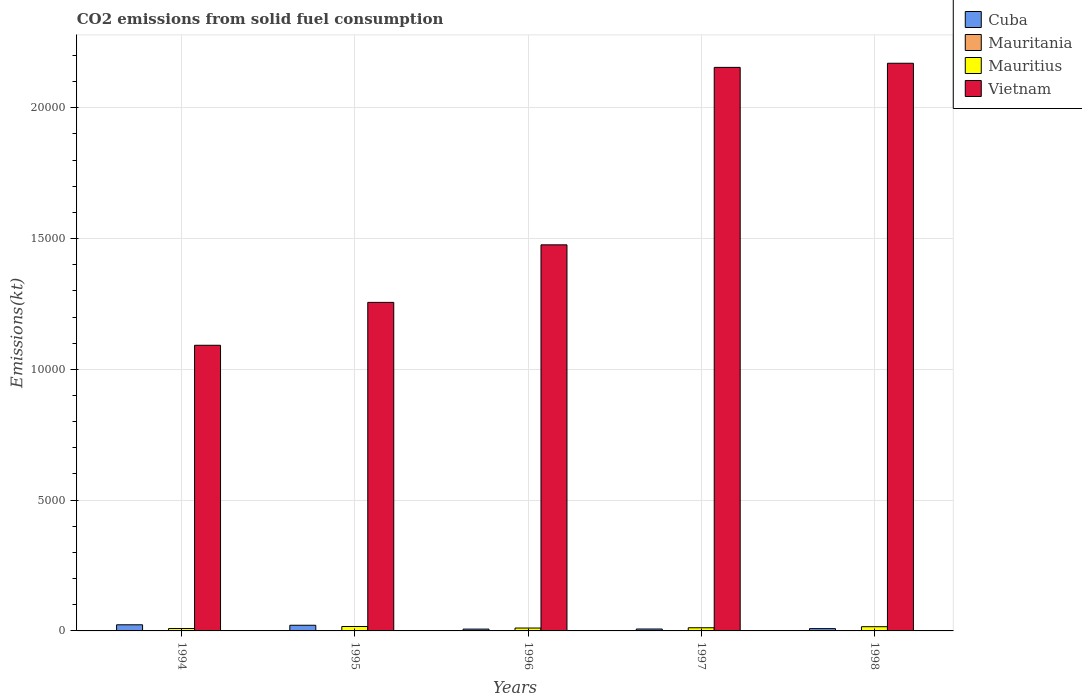How many groups of bars are there?
Offer a terse response. 5. How many bars are there on the 4th tick from the left?
Your response must be concise. 4. How many bars are there on the 1st tick from the right?
Ensure brevity in your answer.  4. What is the amount of CO2 emitted in Mauritius in 1998?
Make the answer very short. 161.35. Across all years, what is the maximum amount of CO2 emitted in Vietnam?
Make the answer very short. 2.17e+04. Across all years, what is the minimum amount of CO2 emitted in Vietnam?
Offer a terse response. 1.09e+04. In which year was the amount of CO2 emitted in Vietnam maximum?
Keep it short and to the point. 1998. In which year was the amount of CO2 emitted in Cuba minimum?
Keep it short and to the point. 1996. What is the total amount of CO2 emitted in Mauritius in the graph?
Your answer should be very brief. 652.73. What is the difference between the amount of CO2 emitted in Cuba in 1995 and that in 1996?
Your response must be concise. 146.68. What is the difference between the amount of CO2 emitted in Mauritius in 1998 and the amount of CO2 emitted in Cuba in 1994?
Your response must be concise. -73.34. What is the average amount of CO2 emitted in Mauritania per year?
Give a very brief answer. 8.07. In the year 1998, what is the difference between the amount of CO2 emitted in Vietnam and amount of CO2 emitted in Cuba?
Provide a succinct answer. 2.16e+04. What is the ratio of the amount of CO2 emitted in Cuba in 1995 to that in 1997?
Offer a very short reply. 2.95. Is the difference between the amount of CO2 emitted in Vietnam in 1996 and 1998 greater than the difference between the amount of CO2 emitted in Cuba in 1996 and 1998?
Give a very brief answer. No. What is the difference between the highest and the second highest amount of CO2 emitted in Vietnam?
Make the answer very short. 157.68. What is the difference between the highest and the lowest amount of CO2 emitted in Cuba?
Your answer should be compact. 165.01. Is it the case that in every year, the sum of the amount of CO2 emitted in Cuba and amount of CO2 emitted in Mauritius is greater than the sum of amount of CO2 emitted in Mauritania and amount of CO2 emitted in Vietnam?
Your answer should be compact. Yes. What does the 3rd bar from the left in 1996 represents?
Your answer should be very brief. Mauritius. What does the 3rd bar from the right in 1997 represents?
Give a very brief answer. Mauritania. Is it the case that in every year, the sum of the amount of CO2 emitted in Cuba and amount of CO2 emitted in Mauritius is greater than the amount of CO2 emitted in Vietnam?
Provide a succinct answer. No. Does the graph contain grids?
Your answer should be very brief. Yes. What is the title of the graph?
Keep it short and to the point. CO2 emissions from solid fuel consumption. Does "Zambia" appear as one of the legend labels in the graph?
Keep it short and to the point. No. What is the label or title of the Y-axis?
Your response must be concise. Emissions(kt). What is the Emissions(kt) in Cuba in 1994?
Your answer should be compact. 234.69. What is the Emissions(kt) in Mauritania in 1994?
Your answer should be very brief. 14.67. What is the Emissions(kt) of Mauritius in 1994?
Give a very brief answer. 91.67. What is the Emissions(kt) of Vietnam in 1994?
Give a very brief answer. 1.09e+04. What is the Emissions(kt) in Cuba in 1995?
Ensure brevity in your answer.  216.35. What is the Emissions(kt) in Mauritania in 1995?
Offer a very short reply. 11. What is the Emissions(kt) of Mauritius in 1995?
Offer a terse response. 168.68. What is the Emissions(kt) of Vietnam in 1995?
Ensure brevity in your answer.  1.26e+04. What is the Emissions(kt) in Cuba in 1996?
Offer a terse response. 69.67. What is the Emissions(kt) of Mauritania in 1996?
Keep it short and to the point. 7.33. What is the Emissions(kt) in Mauritius in 1996?
Provide a short and direct response. 110.01. What is the Emissions(kt) in Vietnam in 1996?
Offer a terse response. 1.48e+04. What is the Emissions(kt) in Cuba in 1997?
Your answer should be compact. 73.34. What is the Emissions(kt) of Mauritania in 1997?
Your response must be concise. 3.67. What is the Emissions(kt) of Mauritius in 1997?
Ensure brevity in your answer.  121.01. What is the Emissions(kt) of Vietnam in 1997?
Ensure brevity in your answer.  2.15e+04. What is the Emissions(kt) in Cuba in 1998?
Provide a short and direct response. 88.01. What is the Emissions(kt) of Mauritania in 1998?
Your answer should be very brief. 3.67. What is the Emissions(kt) of Mauritius in 1998?
Your response must be concise. 161.35. What is the Emissions(kt) in Vietnam in 1998?
Make the answer very short. 2.17e+04. Across all years, what is the maximum Emissions(kt) in Cuba?
Make the answer very short. 234.69. Across all years, what is the maximum Emissions(kt) of Mauritania?
Give a very brief answer. 14.67. Across all years, what is the maximum Emissions(kt) in Mauritius?
Ensure brevity in your answer.  168.68. Across all years, what is the maximum Emissions(kt) of Vietnam?
Keep it short and to the point. 2.17e+04. Across all years, what is the minimum Emissions(kt) of Cuba?
Your response must be concise. 69.67. Across all years, what is the minimum Emissions(kt) in Mauritania?
Give a very brief answer. 3.67. Across all years, what is the minimum Emissions(kt) in Mauritius?
Ensure brevity in your answer.  91.67. Across all years, what is the minimum Emissions(kt) in Vietnam?
Your answer should be compact. 1.09e+04. What is the total Emissions(kt) in Cuba in the graph?
Your answer should be compact. 682.06. What is the total Emissions(kt) in Mauritania in the graph?
Offer a terse response. 40.34. What is the total Emissions(kt) in Mauritius in the graph?
Give a very brief answer. 652.73. What is the total Emissions(kt) of Vietnam in the graph?
Offer a very short reply. 8.15e+04. What is the difference between the Emissions(kt) of Cuba in 1994 and that in 1995?
Your answer should be compact. 18.34. What is the difference between the Emissions(kt) of Mauritania in 1994 and that in 1995?
Provide a succinct answer. 3.67. What is the difference between the Emissions(kt) in Mauritius in 1994 and that in 1995?
Provide a succinct answer. -77.01. What is the difference between the Emissions(kt) of Vietnam in 1994 and that in 1995?
Make the answer very short. -1639.15. What is the difference between the Emissions(kt) in Cuba in 1994 and that in 1996?
Offer a very short reply. 165.01. What is the difference between the Emissions(kt) in Mauritania in 1994 and that in 1996?
Your answer should be very brief. 7.33. What is the difference between the Emissions(kt) of Mauritius in 1994 and that in 1996?
Provide a succinct answer. -18.34. What is the difference between the Emissions(kt) of Vietnam in 1994 and that in 1996?
Offer a terse response. -3839.35. What is the difference between the Emissions(kt) of Cuba in 1994 and that in 1997?
Keep it short and to the point. 161.35. What is the difference between the Emissions(kt) of Mauritania in 1994 and that in 1997?
Give a very brief answer. 11. What is the difference between the Emissions(kt) of Mauritius in 1994 and that in 1997?
Your answer should be compact. -29.34. What is the difference between the Emissions(kt) in Vietnam in 1994 and that in 1997?
Ensure brevity in your answer.  -1.06e+04. What is the difference between the Emissions(kt) in Cuba in 1994 and that in 1998?
Offer a very short reply. 146.68. What is the difference between the Emissions(kt) of Mauritania in 1994 and that in 1998?
Provide a short and direct response. 11. What is the difference between the Emissions(kt) of Mauritius in 1994 and that in 1998?
Ensure brevity in your answer.  -69.67. What is the difference between the Emissions(kt) of Vietnam in 1994 and that in 1998?
Provide a short and direct response. -1.08e+04. What is the difference between the Emissions(kt) of Cuba in 1995 and that in 1996?
Provide a succinct answer. 146.68. What is the difference between the Emissions(kt) of Mauritania in 1995 and that in 1996?
Provide a short and direct response. 3.67. What is the difference between the Emissions(kt) in Mauritius in 1995 and that in 1996?
Your answer should be compact. 58.67. What is the difference between the Emissions(kt) in Vietnam in 1995 and that in 1996?
Provide a short and direct response. -2200.2. What is the difference between the Emissions(kt) of Cuba in 1995 and that in 1997?
Your answer should be very brief. 143.01. What is the difference between the Emissions(kt) of Mauritania in 1995 and that in 1997?
Make the answer very short. 7.33. What is the difference between the Emissions(kt) in Mauritius in 1995 and that in 1997?
Offer a terse response. 47.67. What is the difference between the Emissions(kt) of Vietnam in 1995 and that in 1997?
Your answer should be very brief. -8984.15. What is the difference between the Emissions(kt) of Cuba in 1995 and that in 1998?
Offer a terse response. 128.34. What is the difference between the Emissions(kt) in Mauritania in 1995 and that in 1998?
Offer a terse response. 7.33. What is the difference between the Emissions(kt) in Mauritius in 1995 and that in 1998?
Give a very brief answer. 7.33. What is the difference between the Emissions(kt) of Vietnam in 1995 and that in 1998?
Your response must be concise. -9141.83. What is the difference between the Emissions(kt) of Cuba in 1996 and that in 1997?
Provide a short and direct response. -3.67. What is the difference between the Emissions(kt) of Mauritania in 1996 and that in 1997?
Provide a short and direct response. 3.67. What is the difference between the Emissions(kt) of Mauritius in 1996 and that in 1997?
Provide a succinct answer. -11. What is the difference between the Emissions(kt) in Vietnam in 1996 and that in 1997?
Provide a short and direct response. -6783.95. What is the difference between the Emissions(kt) in Cuba in 1996 and that in 1998?
Keep it short and to the point. -18.34. What is the difference between the Emissions(kt) of Mauritania in 1996 and that in 1998?
Your response must be concise. 3.67. What is the difference between the Emissions(kt) of Mauritius in 1996 and that in 1998?
Offer a very short reply. -51.34. What is the difference between the Emissions(kt) in Vietnam in 1996 and that in 1998?
Ensure brevity in your answer.  -6941.63. What is the difference between the Emissions(kt) of Cuba in 1997 and that in 1998?
Your answer should be very brief. -14.67. What is the difference between the Emissions(kt) of Mauritania in 1997 and that in 1998?
Your answer should be very brief. 0. What is the difference between the Emissions(kt) of Mauritius in 1997 and that in 1998?
Provide a short and direct response. -40.34. What is the difference between the Emissions(kt) of Vietnam in 1997 and that in 1998?
Provide a short and direct response. -157.68. What is the difference between the Emissions(kt) of Cuba in 1994 and the Emissions(kt) of Mauritania in 1995?
Offer a very short reply. 223.69. What is the difference between the Emissions(kt) of Cuba in 1994 and the Emissions(kt) of Mauritius in 1995?
Your answer should be very brief. 66.01. What is the difference between the Emissions(kt) in Cuba in 1994 and the Emissions(kt) in Vietnam in 1995?
Your response must be concise. -1.23e+04. What is the difference between the Emissions(kt) of Mauritania in 1994 and the Emissions(kt) of Mauritius in 1995?
Your answer should be very brief. -154.01. What is the difference between the Emissions(kt) in Mauritania in 1994 and the Emissions(kt) in Vietnam in 1995?
Provide a short and direct response. -1.25e+04. What is the difference between the Emissions(kt) of Mauritius in 1994 and the Emissions(kt) of Vietnam in 1995?
Offer a very short reply. -1.25e+04. What is the difference between the Emissions(kt) in Cuba in 1994 and the Emissions(kt) in Mauritania in 1996?
Give a very brief answer. 227.35. What is the difference between the Emissions(kt) of Cuba in 1994 and the Emissions(kt) of Mauritius in 1996?
Make the answer very short. 124.68. What is the difference between the Emissions(kt) in Cuba in 1994 and the Emissions(kt) in Vietnam in 1996?
Make the answer very short. -1.45e+04. What is the difference between the Emissions(kt) of Mauritania in 1994 and the Emissions(kt) of Mauritius in 1996?
Offer a very short reply. -95.34. What is the difference between the Emissions(kt) of Mauritania in 1994 and the Emissions(kt) of Vietnam in 1996?
Offer a very short reply. -1.47e+04. What is the difference between the Emissions(kt) in Mauritius in 1994 and the Emissions(kt) in Vietnam in 1996?
Ensure brevity in your answer.  -1.47e+04. What is the difference between the Emissions(kt) of Cuba in 1994 and the Emissions(kt) of Mauritania in 1997?
Provide a short and direct response. 231.02. What is the difference between the Emissions(kt) of Cuba in 1994 and the Emissions(kt) of Mauritius in 1997?
Keep it short and to the point. 113.68. What is the difference between the Emissions(kt) in Cuba in 1994 and the Emissions(kt) in Vietnam in 1997?
Offer a very short reply. -2.13e+04. What is the difference between the Emissions(kt) of Mauritania in 1994 and the Emissions(kt) of Mauritius in 1997?
Provide a succinct answer. -106.34. What is the difference between the Emissions(kt) of Mauritania in 1994 and the Emissions(kt) of Vietnam in 1997?
Your answer should be very brief. -2.15e+04. What is the difference between the Emissions(kt) of Mauritius in 1994 and the Emissions(kt) of Vietnam in 1997?
Provide a succinct answer. -2.15e+04. What is the difference between the Emissions(kt) of Cuba in 1994 and the Emissions(kt) of Mauritania in 1998?
Make the answer very short. 231.02. What is the difference between the Emissions(kt) in Cuba in 1994 and the Emissions(kt) in Mauritius in 1998?
Provide a succinct answer. 73.34. What is the difference between the Emissions(kt) of Cuba in 1994 and the Emissions(kt) of Vietnam in 1998?
Provide a short and direct response. -2.15e+04. What is the difference between the Emissions(kt) in Mauritania in 1994 and the Emissions(kt) in Mauritius in 1998?
Offer a very short reply. -146.68. What is the difference between the Emissions(kt) of Mauritania in 1994 and the Emissions(kt) of Vietnam in 1998?
Offer a terse response. -2.17e+04. What is the difference between the Emissions(kt) of Mauritius in 1994 and the Emissions(kt) of Vietnam in 1998?
Give a very brief answer. -2.16e+04. What is the difference between the Emissions(kt) of Cuba in 1995 and the Emissions(kt) of Mauritania in 1996?
Offer a very short reply. 209.02. What is the difference between the Emissions(kt) of Cuba in 1995 and the Emissions(kt) of Mauritius in 1996?
Ensure brevity in your answer.  106.34. What is the difference between the Emissions(kt) in Cuba in 1995 and the Emissions(kt) in Vietnam in 1996?
Offer a very short reply. -1.45e+04. What is the difference between the Emissions(kt) of Mauritania in 1995 and the Emissions(kt) of Mauritius in 1996?
Provide a short and direct response. -99.01. What is the difference between the Emissions(kt) in Mauritania in 1995 and the Emissions(kt) in Vietnam in 1996?
Your response must be concise. -1.47e+04. What is the difference between the Emissions(kt) of Mauritius in 1995 and the Emissions(kt) of Vietnam in 1996?
Keep it short and to the point. -1.46e+04. What is the difference between the Emissions(kt) in Cuba in 1995 and the Emissions(kt) in Mauritania in 1997?
Offer a terse response. 212.69. What is the difference between the Emissions(kt) in Cuba in 1995 and the Emissions(kt) in Mauritius in 1997?
Provide a succinct answer. 95.34. What is the difference between the Emissions(kt) in Cuba in 1995 and the Emissions(kt) in Vietnam in 1997?
Your response must be concise. -2.13e+04. What is the difference between the Emissions(kt) in Mauritania in 1995 and the Emissions(kt) in Mauritius in 1997?
Your answer should be very brief. -110.01. What is the difference between the Emissions(kt) in Mauritania in 1995 and the Emissions(kt) in Vietnam in 1997?
Your answer should be very brief. -2.15e+04. What is the difference between the Emissions(kt) of Mauritius in 1995 and the Emissions(kt) of Vietnam in 1997?
Keep it short and to the point. -2.14e+04. What is the difference between the Emissions(kt) in Cuba in 1995 and the Emissions(kt) in Mauritania in 1998?
Ensure brevity in your answer.  212.69. What is the difference between the Emissions(kt) in Cuba in 1995 and the Emissions(kt) in Mauritius in 1998?
Provide a short and direct response. 55.01. What is the difference between the Emissions(kt) in Cuba in 1995 and the Emissions(kt) in Vietnam in 1998?
Your answer should be compact. -2.15e+04. What is the difference between the Emissions(kt) in Mauritania in 1995 and the Emissions(kt) in Mauritius in 1998?
Provide a succinct answer. -150.35. What is the difference between the Emissions(kt) of Mauritania in 1995 and the Emissions(kt) of Vietnam in 1998?
Provide a succinct answer. -2.17e+04. What is the difference between the Emissions(kt) in Mauritius in 1995 and the Emissions(kt) in Vietnam in 1998?
Make the answer very short. -2.15e+04. What is the difference between the Emissions(kt) in Cuba in 1996 and the Emissions(kt) in Mauritania in 1997?
Your answer should be compact. 66.01. What is the difference between the Emissions(kt) of Cuba in 1996 and the Emissions(kt) of Mauritius in 1997?
Give a very brief answer. -51.34. What is the difference between the Emissions(kt) in Cuba in 1996 and the Emissions(kt) in Vietnam in 1997?
Provide a short and direct response. -2.15e+04. What is the difference between the Emissions(kt) in Mauritania in 1996 and the Emissions(kt) in Mauritius in 1997?
Your answer should be compact. -113.68. What is the difference between the Emissions(kt) of Mauritania in 1996 and the Emissions(kt) of Vietnam in 1997?
Give a very brief answer. -2.15e+04. What is the difference between the Emissions(kt) in Mauritius in 1996 and the Emissions(kt) in Vietnam in 1997?
Make the answer very short. -2.14e+04. What is the difference between the Emissions(kt) of Cuba in 1996 and the Emissions(kt) of Mauritania in 1998?
Make the answer very short. 66.01. What is the difference between the Emissions(kt) of Cuba in 1996 and the Emissions(kt) of Mauritius in 1998?
Keep it short and to the point. -91.67. What is the difference between the Emissions(kt) of Cuba in 1996 and the Emissions(kt) of Vietnam in 1998?
Your response must be concise. -2.16e+04. What is the difference between the Emissions(kt) of Mauritania in 1996 and the Emissions(kt) of Mauritius in 1998?
Keep it short and to the point. -154.01. What is the difference between the Emissions(kt) in Mauritania in 1996 and the Emissions(kt) in Vietnam in 1998?
Your answer should be very brief. -2.17e+04. What is the difference between the Emissions(kt) in Mauritius in 1996 and the Emissions(kt) in Vietnam in 1998?
Your answer should be very brief. -2.16e+04. What is the difference between the Emissions(kt) in Cuba in 1997 and the Emissions(kt) in Mauritania in 1998?
Keep it short and to the point. 69.67. What is the difference between the Emissions(kt) of Cuba in 1997 and the Emissions(kt) of Mauritius in 1998?
Ensure brevity in your answer.  -88.01. What is the difference between the Emissions(kt) of Cuba in 1997 and the Emissions(kt) of Vietnam in 1998?
Your answer should be compact. -2.16e+04. What is the difference between the Emissions(kt) of Mauritania in 1997 and the Emissions(kt) of Mauritius in 1998?
Give a very brief answer. -157.68. What is the difference between the Emissions(kt) in Mauritania in 1997 and the Emissions(kt) in Vietnam in 1998?
Make the answer very short. -2.17e+04. What is the difference between the Emissions(kt) in Mauritius in 1997 and the Emissions(kt) in Vietnam in 1998?
Provide a succinct answer. -2.16e+04. What is the average Emissions(kt) of Cuba per year?
Offer a terse response. 136.41. What is the average Emissions(kt) of Mauritania per year?
Give a very brief answer. 8.07. What is the average Emissions(kt) of Mauritius per year?
Give a very brief answer. 130.55. What is the average Emissions(kt) of Vietnam per year?
Provide a succinct answer. 1.63e+04. In the year 1994, what is the difference between the Emissions(kt) in Cuba and Emissions(kt) in Mauritania?
Keep it short and to the point. 220.02. In the year 1994, what is the difference between the Emissions(kt) of Cuba and Emissions(kt) of Mauritius?
Give a very brief answer. 143.01. In the year 1994, what is the difference between the Emissions(kt) of Cuba and Emissions(kt) of Vietnam?
Your answer should be very brief. -1.07e+04. In the year 1994, what is the difference between the Emissions(kt) of Mauritania and Emissions(kt) of Mauritius?
Your answer should be compact. -77.01. In the year 1994, what is the difference between the Emissions(kt) of Mauritania and Emissions(kt) of Vietnam?
Give a very brief answer. -1.09e+04. In the year 1994, what is the difference between the Emissions(kt) of Mauritius and Emissions(kt) of Vietnam?
Make the answer very short. -1.08e+04. In the year 1995, what is the difference between the Emissions(kt) of Cuba and Emissions(kt) of Mauritania?
Offer a terse response. 205.35. In the year 1995, what is the difference between the Emissions(kt) in Cuba and Emissions(kt) in Mauritius?
Ensure brevity in your answer.  47.67. In the year 1995, what is the difference between the Emissions(kt) in Cuba and Emissions(kt) in Vietnam?
Make the answer very short. -1.23e+04. In the year 1995, what is the difference between the Emissions(kt) of Mauritania and Emissions(kt) of Mauritius?
Offer a very short reply. -157.68. In the year 1995, what is the difference between the Emissions(kt) in Mauritania and Emissions(kt) in Vietnam?
Your answer should be compact. -1.25e+04. In the year 1995, what is the difference between the Emissions(kt) of Mauritius and Emissions(kt) of Vietnam?
Your response must be concise. -1.24e+04. In the year 1996, what is the difference between the Emissions(kt) in Cuba and Emissions(kt) in Mauritania?
Your answer should be very brief. 62.34. In the year 1996, what is the difference between the Emissions(kt) in Cuba and Emissions(kt) in Mauritius?
Your response must be concise. -40.34. In the year 1996, what is the difference between the Emissions(kt) in Cuba and Emissions(kt) in Vietnam?
Make the answer very short. -1.47e+04. In the year 1996, what is the difference between the Emissions(kt) of Mauritania and Emissions(kt) of Mauritius?
Your response must be concise. -102.68. In the year 1996, what is the difference between the Emissions(kt) of Mauritania and Emissions(kt) of Vietnam?
Provide a short and direct response. -1.48e+04. In the year 1996, what is the difference between the Emissions(kt) of Mauritius and Emissions(kt) of Vietnam?
Your response must be concise. -1.46e+04. In the year 1997, what is the difference between the Emissions(kt) in Cuba and Emissions(kt) in Mauritania?
Ensure brevity in your answer.  69.67. In the year 1997, what is the difference between the Emissions(kt) of Cuba and Emissions(kt) of Mauritius?
Keep it short and to the point. -47.67. In the year 1997, what is the difference between the Emissions(kt) in Cuba and Emissions(kt) in Vietnam?
Provide a short and direct response. -2.15e+04. In the year 1997, what is the difference between the Emissions(kt) of Mauritania and Emissions(kt) of Mauritius?
Your answer should be very brief. -117.34. In the year 1997, what is the difference between the Emissions(kt) in Mauritania and Emissions(kt) in Vietnam?
Provide a succinct answer. -2.15e+04. In the year 1997, what is the difference between the Emissions(kt) of Mauritius and Emissions(kt) of Vietnam?
Your answer should be compact. -2.14e+04. In the year 1998, what is the difference between the Emissions(kt) in Cuba and Emissions(kt) in Mauritania?
Your answer should be compact. 84.34. In the year 1998, what is the difference between the Emissions(kt) in Cuba and Emissions(kt) in Mauritius?
Provide a succinct answer. -73.34. In the year 1998, what is the difference between the Emissions(kt) of Cuba and Emissions(kt) of Vietnam?
Your answer should be very brief. -2.16e+04. In the year 1998, what is the difference between the Emissions(kt) in Mauritania and Emissions(kt) in Mauritius?
Keep it short and to the point. -157.68. In the year 1998, what is the difference between the Emissions(kt) of Mauritania and Emissions(kt) of Vietnam?
Ensure brevity in your answer.  -2.17e+04. In the year 1998, what is the difference between the Emissions(kt) in Mauritius and Emissions(kt) in Vietnam?
Ensure brevity in your answer.  -2.15e+04. What is the ratio of the Emissions(kt) of Cuba in 1994 to that in 1995?
Your answer should be very brief. 1.08. What is the ratio of the Emissions(kt) of Mauritania in 1994 to that in 1995?
Keep it short and to the point. 1.33. What is the ratio of the Emissions(kt) in Mauritius in 1994 to that in 1995?
Provide a short and direct response. 0.54. What is the ratio of the Emissions(kt) in Vietnam in 1994 to that in 1995?
Offer a very short reply. 0.87. What is the ratio of the Emissions(kt) in Cuba in 1994 to that in 1996?
Offer a very short reply. 3.37. What is the ratio of the Emissions(kt) of Mauritania in 1994 to that in 1996?
Your answer should be very brief. 2. What is the ratio of the Emissions(kt) in Mauritius in 1994 to that in 1996?
Your response must be concise. 0.83. What is the ratio of the Emissions(kt) of Vietnam in 1994 to that in 1996?
Give a very brief answer. 0.74. What is the ratio of the Emissions(kt) in Cuba in 1994 to that in 1997?
Your answer should be very brief. 3.2. What is the ratio of the Emissions(kt) of Mauritius in 1994 to that in 1997?
Your answer should be compact. 0.76. What is the ratio of the Emissions(kt) of Vietnam in 1994 to that in 1997?
Give a very brief answer. 0.51. What is the ratio of the Emissions(kt) of Cuba in 1994 to that in 1998?
Keep it short and to the point. 2.67. What is the ratio of the Emissions(kt) in Mauritania in 1994 to that in 1998?
Keep it short and to the point. 4. What is the ratio of the Emissions(kt) of Mauritius in 1994 to that in 1998?
Offer a very short reply. 0.57. What is the ratio of the Emissions(kt) in Vietnam in 1994 to that in 1998?
Your answer should be very brief. 0.5. What is the ratio of the Emissions(kt) in Cuba in 1995 to that in 1996?
Provide a succinct answer. 3.11. What is the ratio of the Emissions(kt) in Mauritania in 1995 to that in 1996?
Your answer should be compact. 1.5. What is the ratio of the Emissions(kt) of Mauritius in 1995 to that in 1996?
Offer a terse response. 1.53. What is the ratio of the Emissions(kt) in Vietnam in 1995 to that in 1996?
Keep it short and to the point. 0.85. What is the ratio of the Emissions(kt) of Cuba in 1995 to that in 1997?
Your response must be concise. 2.95. What is the ratio of the Emissions(kt) of Mauritania in 1995 to that in 1997?
Provide a succinct answer. 3. What is the ratio of the Emissions(kt) of Mauritius in 1995 to that in 1997?
Make the answer very short. 1.39. What is the ratio of the Emissions(kt) in Vietnam in 1995 to that in 1997?
Your response must be concise. 0.58. What is the ratio of the Emissions(kt) of Cuba in 1995 to that in 1998?
Give a very brief answer. 2.46. What is the ratio of the Emissions(kt) of Mauritania in 1995 to that in 1998?
Give a very brief answer. 3. What is the ratio of the Emissions(kt) in Mauritius in 1995 to that in 1998?
Give a very brief answer. 1.05. What is the ratio of the Emissions(kt) in Vietnam in 1995 to that in 1998?
Provide a short and direct response. 0.58. What is the ratio of the Emissions(kt) in Mauritius in 1996 to that in 1997?
Ensure brevity in your answer.  0.91. What is the ratio of the Emissions(kt) of Vietnam in 1996 to that in 1997?
Your answer should be very brief. 0.69. What is the ratio of the Emissions(kt) of Cuba in 1996 to that in 1998?
Your answer should be compact. 0.79. What is the ratio of the Emissions(kt) in Mauritius in 1996 to that in 1998?
Offer a very short reply. 0.68. What is the ratio of the Emissions(kt) in Vietnam in 1996 to that in 1998?
Ensure brevity in your answer.  0.68. What is the ratio of the Emissions(kt) in Mauritius in 1997 to that in 1998?
Provide a short and direct response. 0.75. What is the difference between the highest and the second highest Emissions(kt) in Cuba?
Keep it short and to the point. 18.34. What is the difference between the highest and the second highest Emissions(kt) in Mauritania?
Your answer should be very brief. 3.67. What is the difference between the highest and the second highest Emissions(kt) of Mauritius?
Your answer should be very brief. 7.33. What is the difference between the highest and the second highest Emissions(kt) of Vietnam?
Make the answer very short. 157.68. What is the difference between the highest and the lowest Emissions(kt) in Cuba?
Keep it short and to the point. 165.01. What is the difference between the highest and the lowest Emissions(kt) of Mauritania?
Make the answer very short. 11. What is the difference between the highest and the lowest Emissions(kt) in Mauritius?
Offer a very short reply. 77.01. What is the difference between the highest and the lowest Emissions(kt) in Vietnam?
Your answer should be very brief. 1.08e+04. 